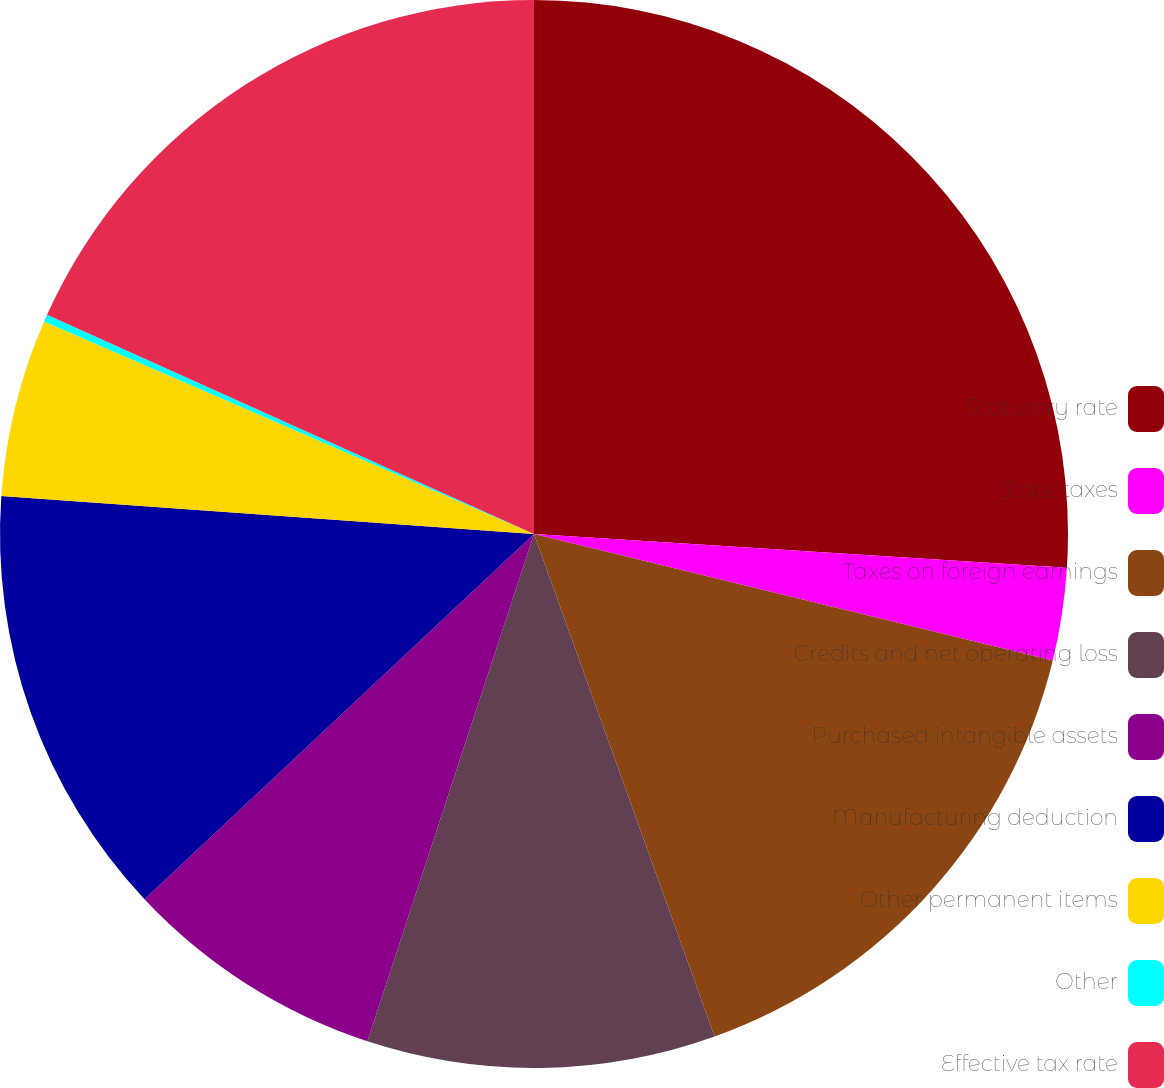<chart> <loc_0><loc_0><loc_500><loc_500><pie_chart><fcel>Statutory rate<fcel>State taxes<fcel>Taxes on foreign earnings<fcel>Credits and net operating loss<fcel>Purchased intangible assets<fcel>Manufacturing deduction<fcel>Other permanent items<fcel>Other<fcel>Effective tax rate<nl><fcel>26.01%<fcel>2.8%<fcel>15.7%<fcel>10.54%<fcel>7.96%<fcel>13.12%<fcel>5.38%<fcel>0.22%<fcel>18.27%<nl></chart> 